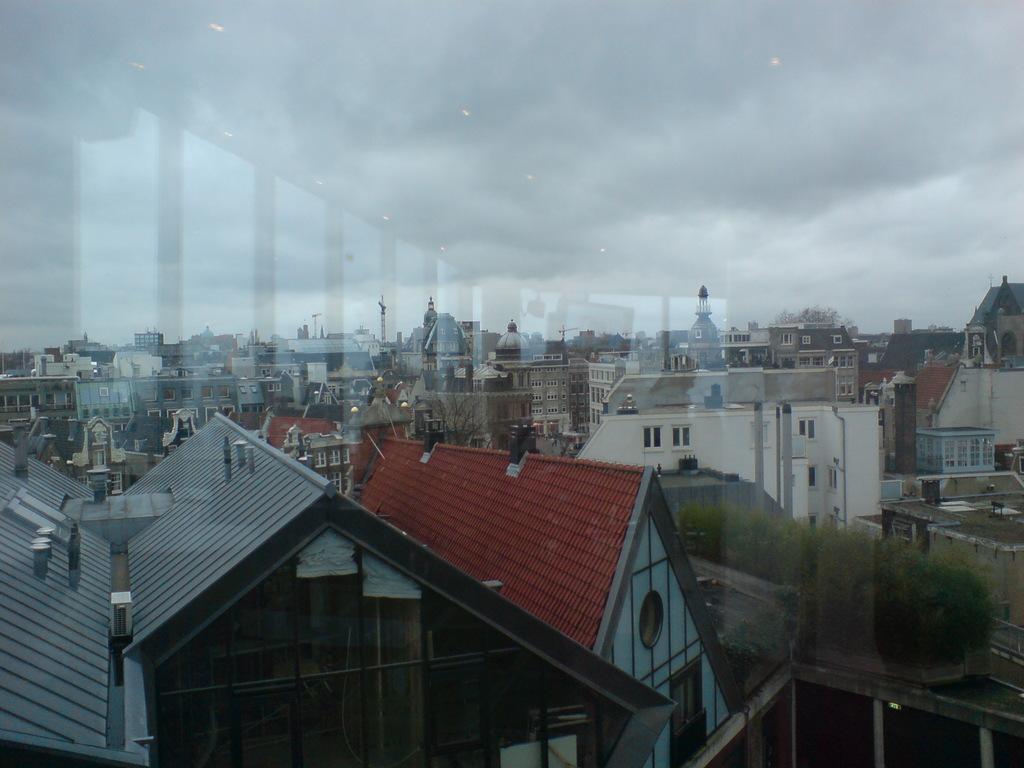Please provide a concise description of this image. In this image we can see the glass window through which we can see the buildings, trees and the cloudy sky in the background. Here we can see the reflection of lights on the glass window. 